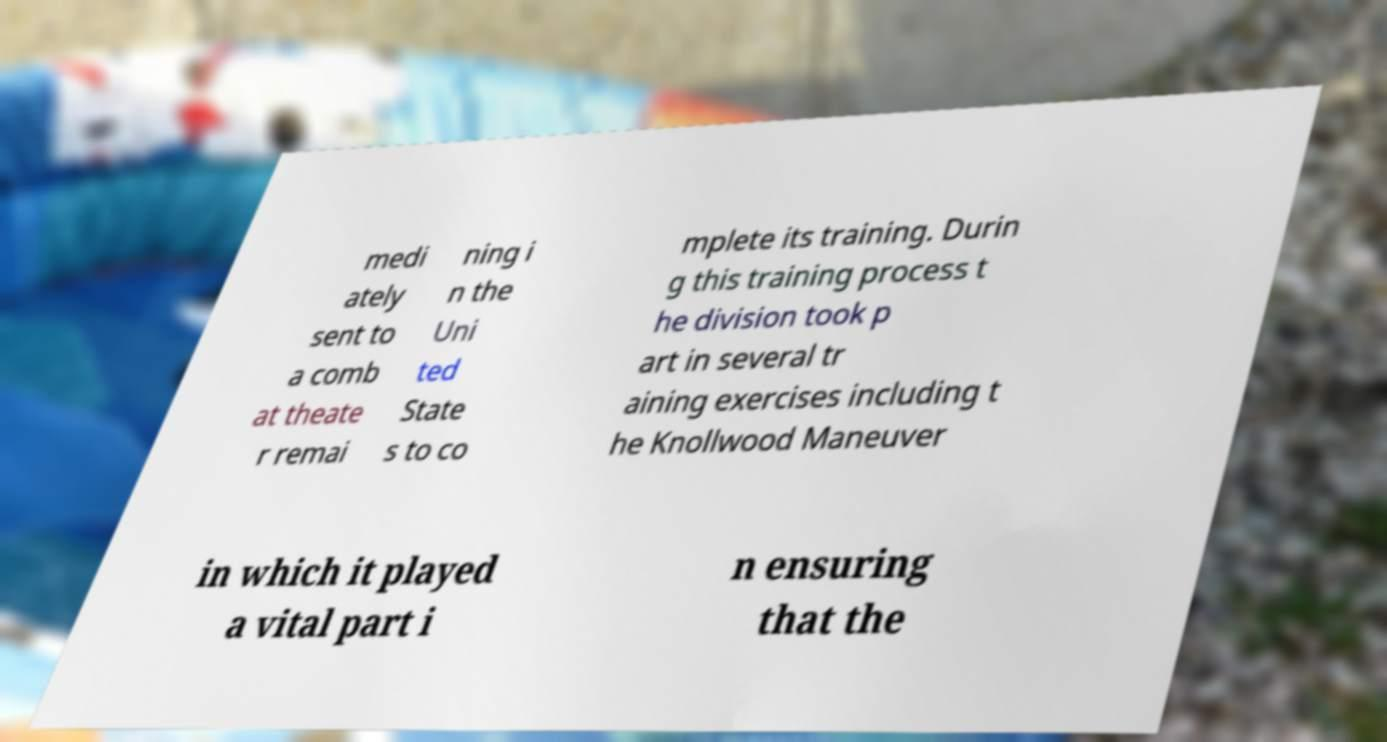Can you accurately transcribe the text from the provided image for me? medi ately sent to a comb at theate r remai ning i n the Uni ted State s to co mplete its training. Durin g this training process t he division took p art in several tr aining exercises including t he Knollwood Maneuver in which it played a vital part i n ensuring that the 